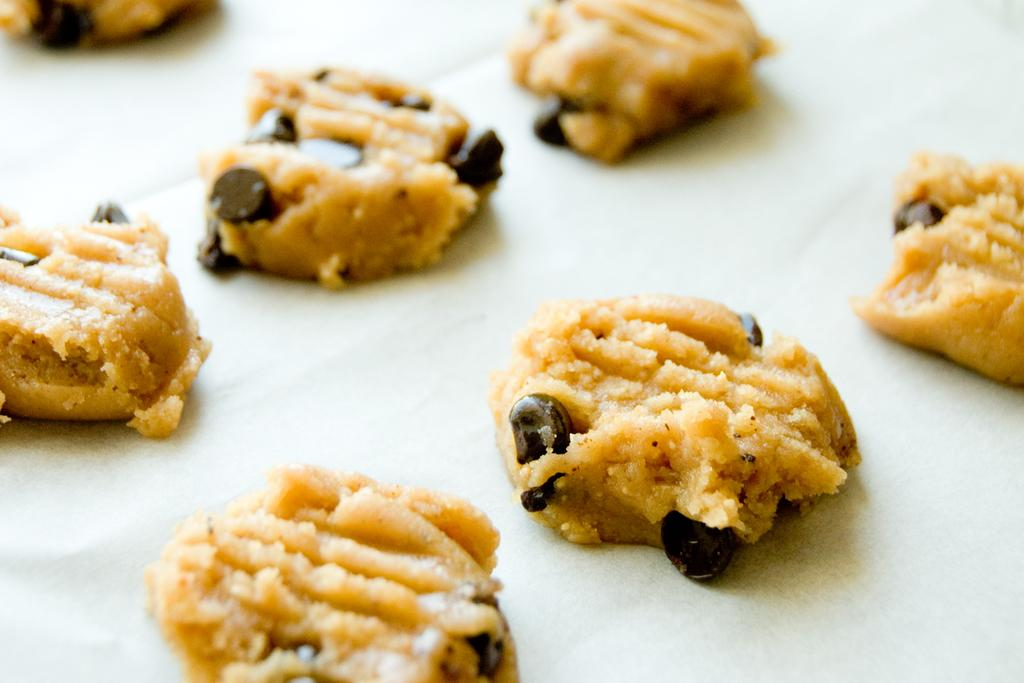What type of cookies are visible in the image? There are chocolate chip cookies in the image. What is the color of the surface on which the cookies are placed? The cookies are on a white surface. What type of pail is used to serve the cookies in the image? There is no pail present in the image; the cookies are on a white surface. What is the main course of the lunch depicted in the image? There is no lunch depicted in the image; it only shows chocolate chip cookies on a white surface. 